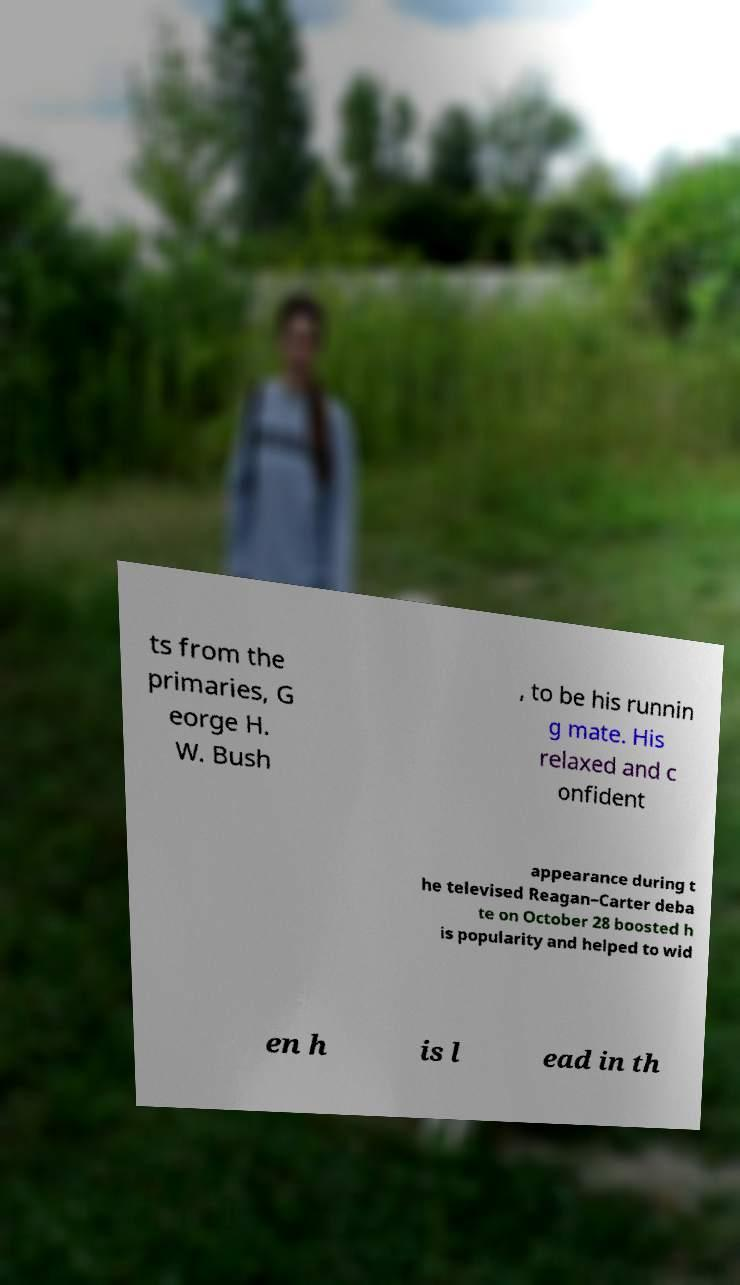For documentation purposes, I need the text within this image transcribed. Could you provide that? ts from the primaries, G eorge H. W. Bush , to be his runnin g mate. His relaxed and c onfident appearance during t he televised Reagan–Carter deba te on October 28 boosted h is popularity and helped to wid en h is l ead in th 